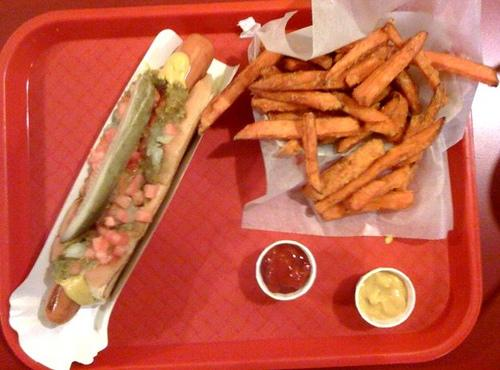What is on the left of the tray? hot dog 